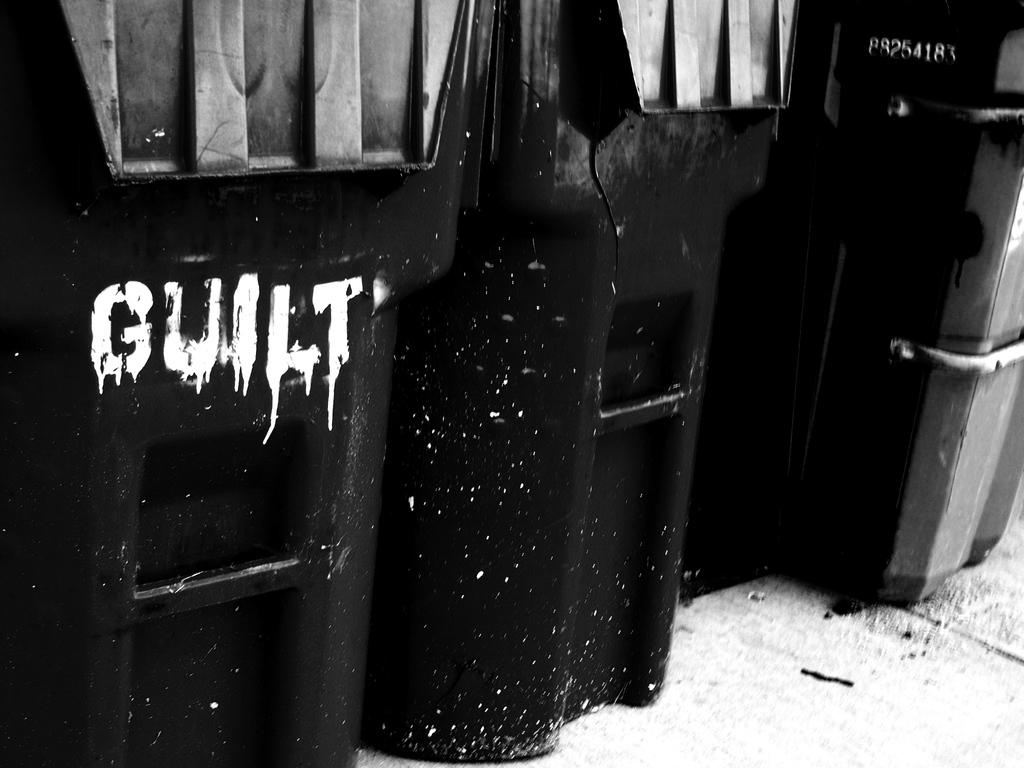<image>
Present a compact description of the photo's key features. A black container has "guilt" painted in white. 